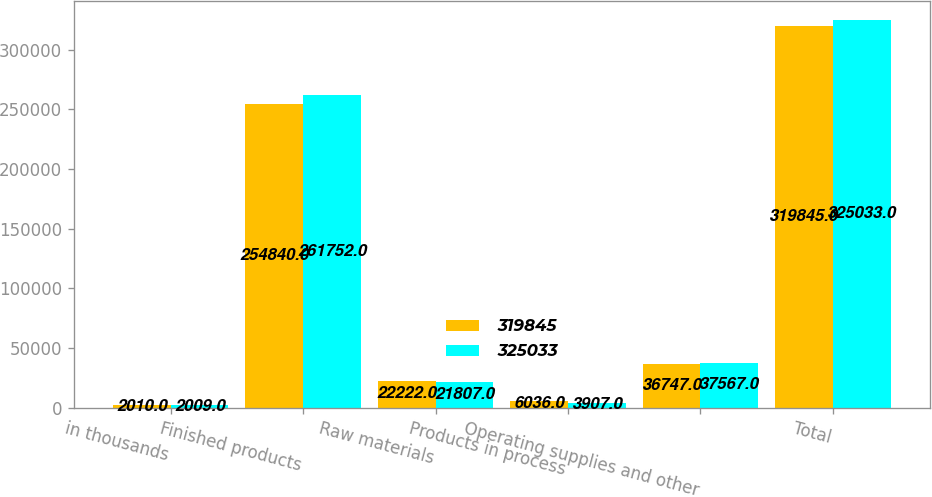Convert chart. <chart><loc_0><loc_0><loc_500><loc_500><stacked_bar_chart><ecel><fcel>in thousands<fcel>Finished products<fcel>Raw materials<fcel>Products in process<fcel>Operating supplies and other<fcel>Total<nl><fcel>319845<fcel>2010<fcel>254840<fcel>22222<fcel>6036<fcel>36747<fcel>319845<nl><fcel>325033<fcel>2009<fcel>261752<fcel>21807<fcel>3907<fcel>37567<fcel>325033<nl></chart> 